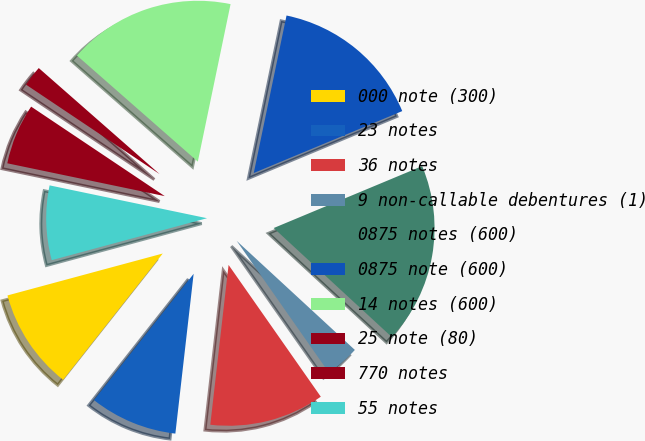Convert chart to OTSL. <chart><loc_0><loc_0><loc_500><loc_500><pie_chart><fcel>000 note (300)<fcel>23 notes<fcel>36 notes<fcel>9 non-callable debentures (1)<fcel>0875 notes (600)<fcel>0875 note (600)<fcel>14 notes (600)<fcel>25 note (80)<fcel>770 notes<fcel>55 notes<nl><fcel>10.17%<fcel>8.82%<fcel>11.53%<fcel>3.42%<fcel>18.15%<fcel>15.45%<fcel>16.8%<fcel>2.07%<fcel>6.12%<fcel>7.47%<nl></chart> 